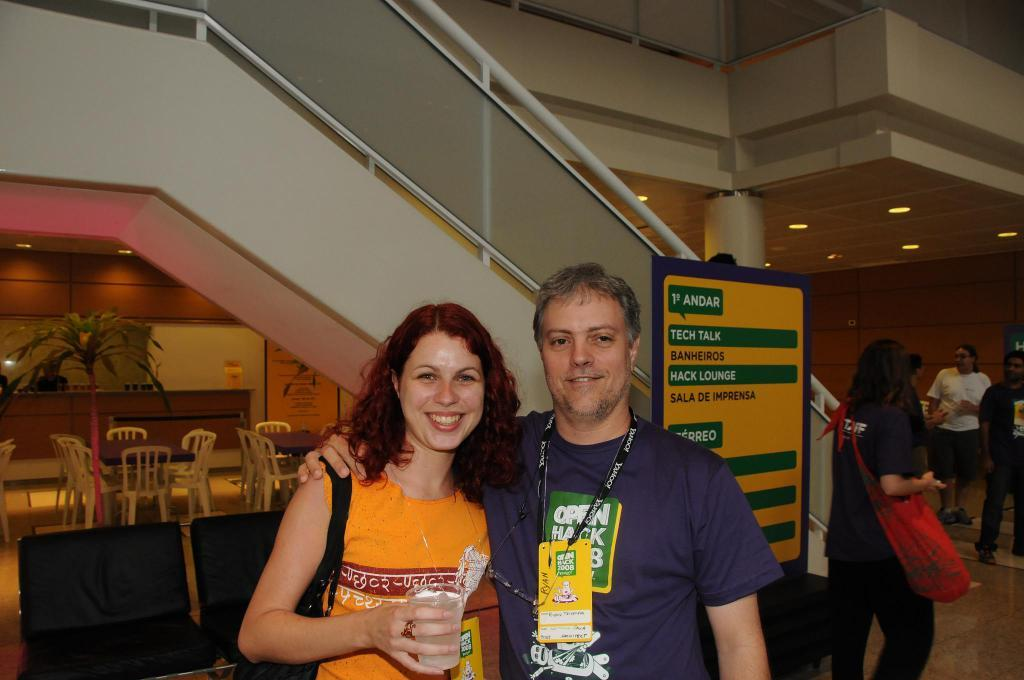How many people are in the image? There are people in the image, but the exact number is not specified. What type of furniture is present in the image? There are chairs and a table in the image. What is the purpose of the desk in the image? The desk is likely used for work or study, as there are objects on it. What can be seen on the roof in the image? There are lights on the roof in the image. What architectural elements are present in the image? There are pillars and a railing in the image. What type of decorations are present in the image? There are posters in the image. What type of patch is sewn onto the crate in the image? There is no crate or patch present in the image. 